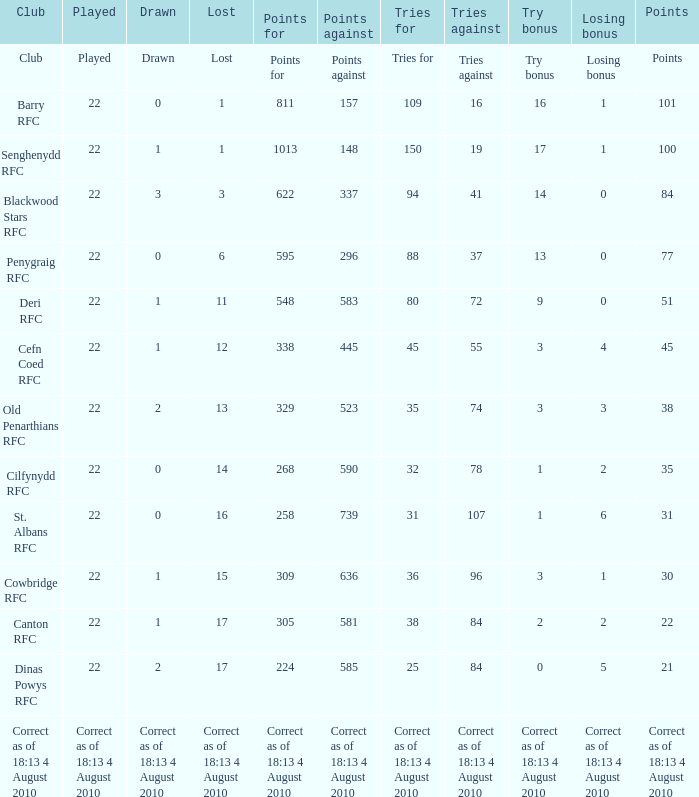What is the total number of games played when attempts against are 84, and draws are 2? 22.0. 